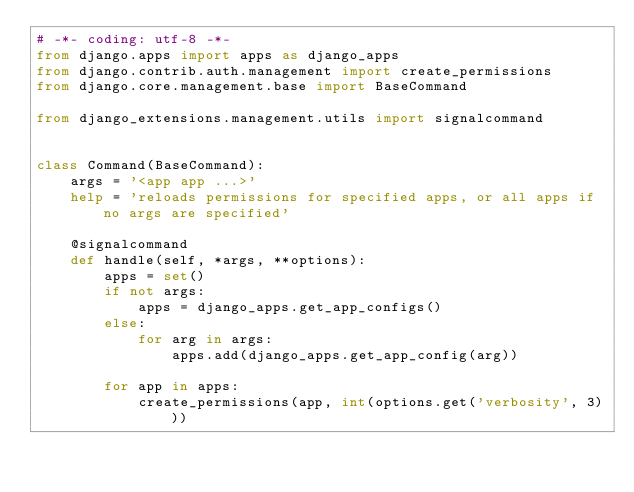<code> <loc_0><loc_0><loc_500><loc_500><_Python_># -*- coding: utf-8 -*-
from django.apps import apps as django_apps
from django.contrib.auth.management import create_permissions
from django.core.management.base import BaseCommand

from django_extensions.management.utils import signalcommand


class Command(BaseCommand):
    args = '<app app ...>'
    help = 'reloads permissions for specified apps, or all apps if no args are specified'

    @signalcommand
    def handle(self, *args, **options):
        apps = set()
        if not args:
            apps = django_apps.get_app_configs()
        else:
            for arg in args:
                apps.add(django_apps.get_app_config(arg))

        for app in apps:
            create_permissions(app, int(options.get('verbosity', 3)))
</code> 